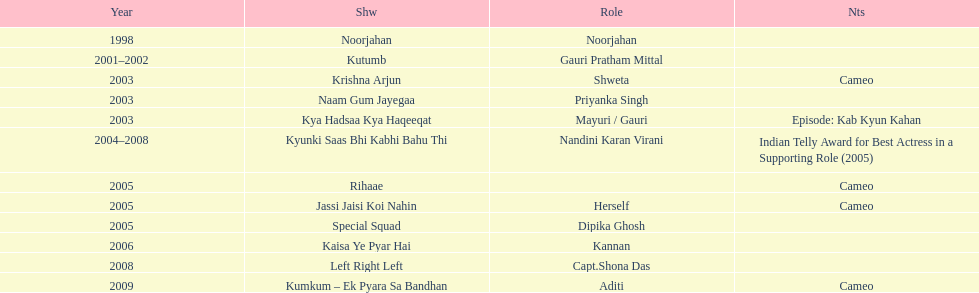Besides rihaae, in what other show did gauri tejwani cameo in 2005? Jassi Jaisi Koi Nahin. 